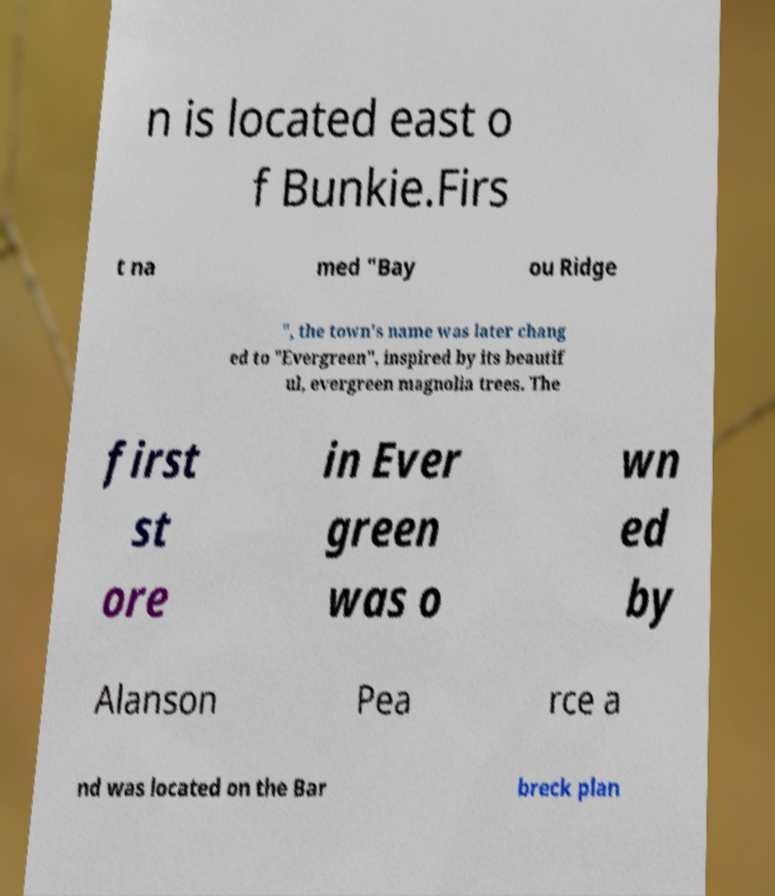Please read and relay the text visible in this image. What does it say? n is located east o f Bunkie.Firs t na med "Bay ou Ridge ", the town's name was later chang ed to "Evergreen", inspired by its beautif ul, evergreen magnolia trees. The first st ore in Ever green was o wn ed by Alanson Pea rce a nd was located on the Bar breck plan 